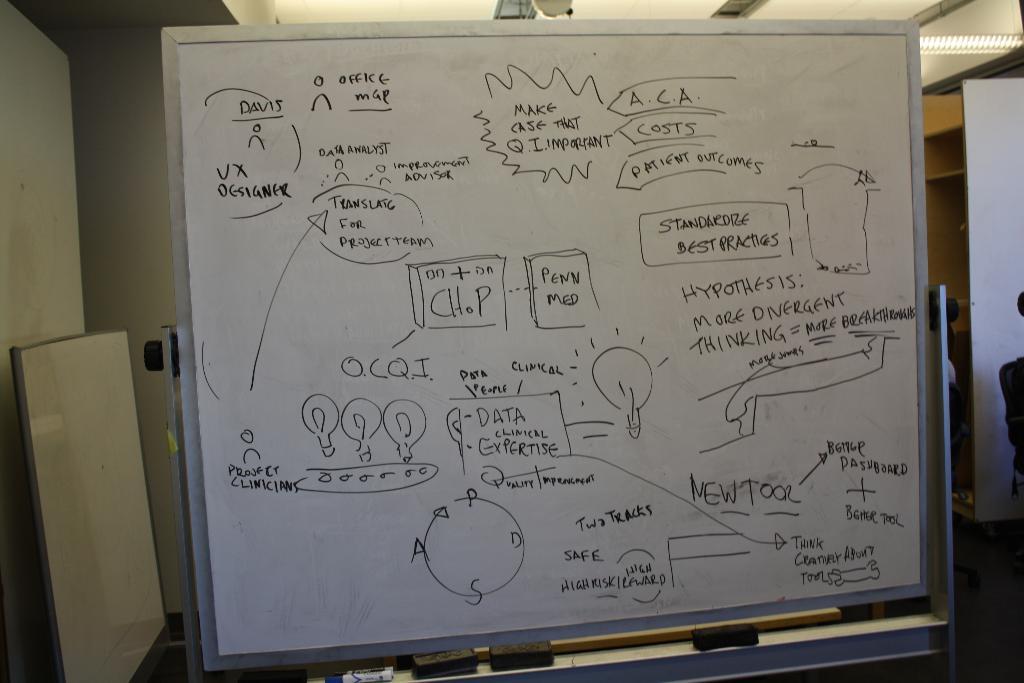What does this white board have on it?
Provide a short and direct response. Unanswerable. What is the hypothesis of the lesson?
Provide a succinct answer. More divergent thinking = more breakthroughs. 